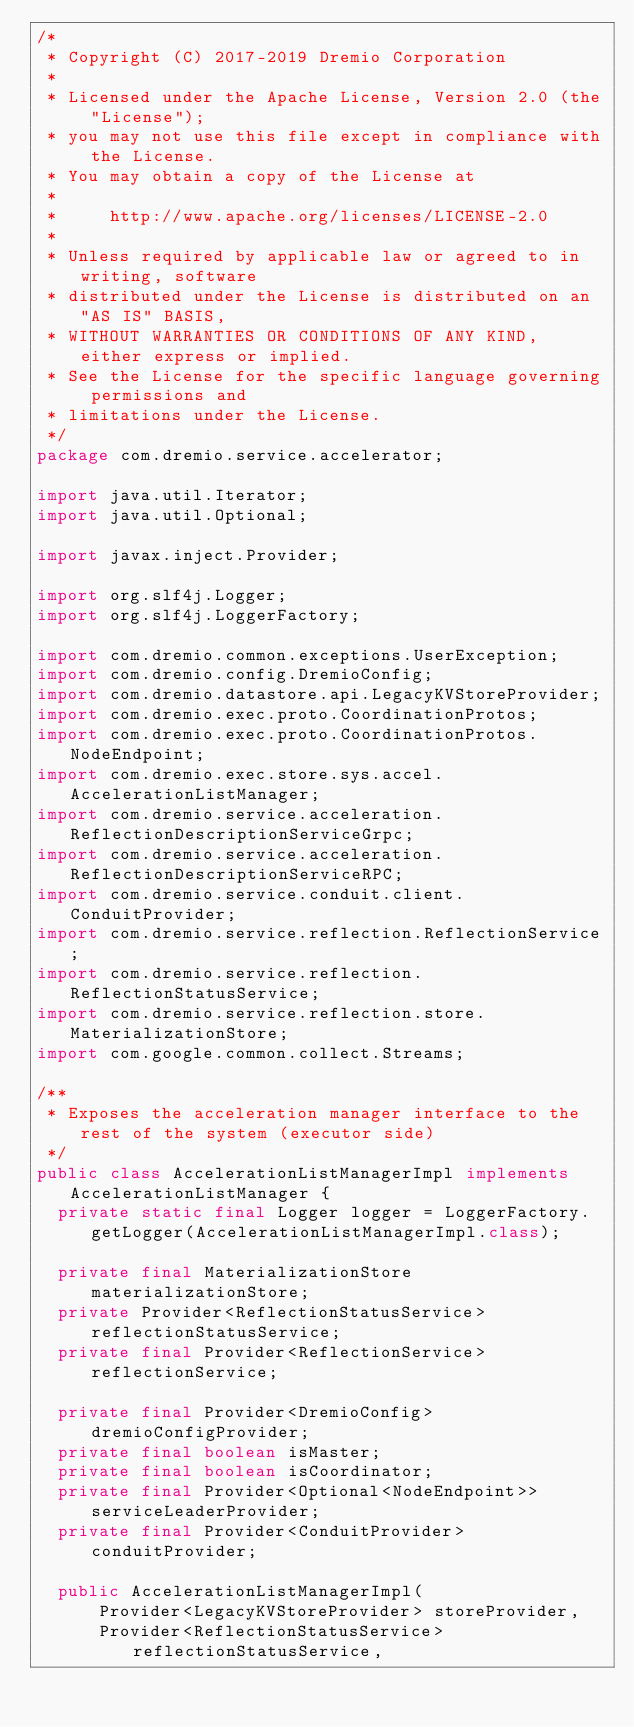Convert code to text. <code><loc_0><loc_0><loc_500><loc_500><_Java_>/*
 * Copyright (C) 2017-2019 Dremio Corporation
 *
 * Licensed under the Apache License, Version 2.0 (the "License");
 * you may not use this file except in compliance with the License.
 * You may obtain a copy of the License at
 *
 *     http://www.apache.org/licenses/LICENSE-2.0
 *
 * Unless required by applicable law or agreed to in writing, software
 * distributed under the License is distributed on an "AS IS" BASIS,
 * WITHOUT WARRANTIES OR CONDITIONS OF ANY KIND, either express or implied.
 * See the License for the specific language governing permissions and
 * limitations under the License.
 */
package com.dremio.service.accelerator;

import java.util.Iterator;
import java.util.Optional;

import javax.inject.Provider;

import org.slf4j.Logger;
import org.slf4j.LoggerFactory;

import com.dremio.common.exceptions.UserException;
import com.dremio.config.DremioConfig;
import com.dremio.datastore.api.LegacyKVStoreProvider;
import com.dremio.exec.proto.CoordinationProtos;
import com.dremio.exec.proto.CoordinationProtos.NodeEndpoint;
import com.dremio.exec.store.sys.accel.AccelerationListManager;
import com.dremio.service.acceleration.ReflectionDescriptionServiceGrpc;
import com.dremio.service.acceleration.ReflectionDescriptionServiceRPC;
import com.dremio.service.conduit.client.ConduitProvider;
import com.dremio.service.reflection.ReflectionService;
import com.dremio.service.reflection.ReflectionStatusService;
import com.dremio.service.reflection.store.MaterializationStore;
import com.google.common.collect.Streams;

/**
 * Exposes the acceleration manager interface to the rest of the system (executor side)
 */
public class AccelerationListManagerImpl implements AccelerationListManager {
  private static final Logger logger = LoggerFactory.getLogger(AccelerationListManagerImpl.class);

  private final MaterializationStore materializationStore;
  private Provider<ReflectionStatusService> reflectionStatusService;
  private final Provider<ReflectionService> reflectionService;

  private final Provider<DremioConfig> dremioConfigProvider;
  private final boolean isMaster;
  private final boolean isCoordinator;
  private final Provider<Optional<NodeEndpoint>> serviceLeaderProvider;
  private final Provider<ConduitProvider> conduitProvider;

  public AccelerationListManagerImpl(
      Provider<LegacyKVStoreProvider> storeProvider,
      Provider<ReflectionStatusService> reflectionStatusService,</code> 